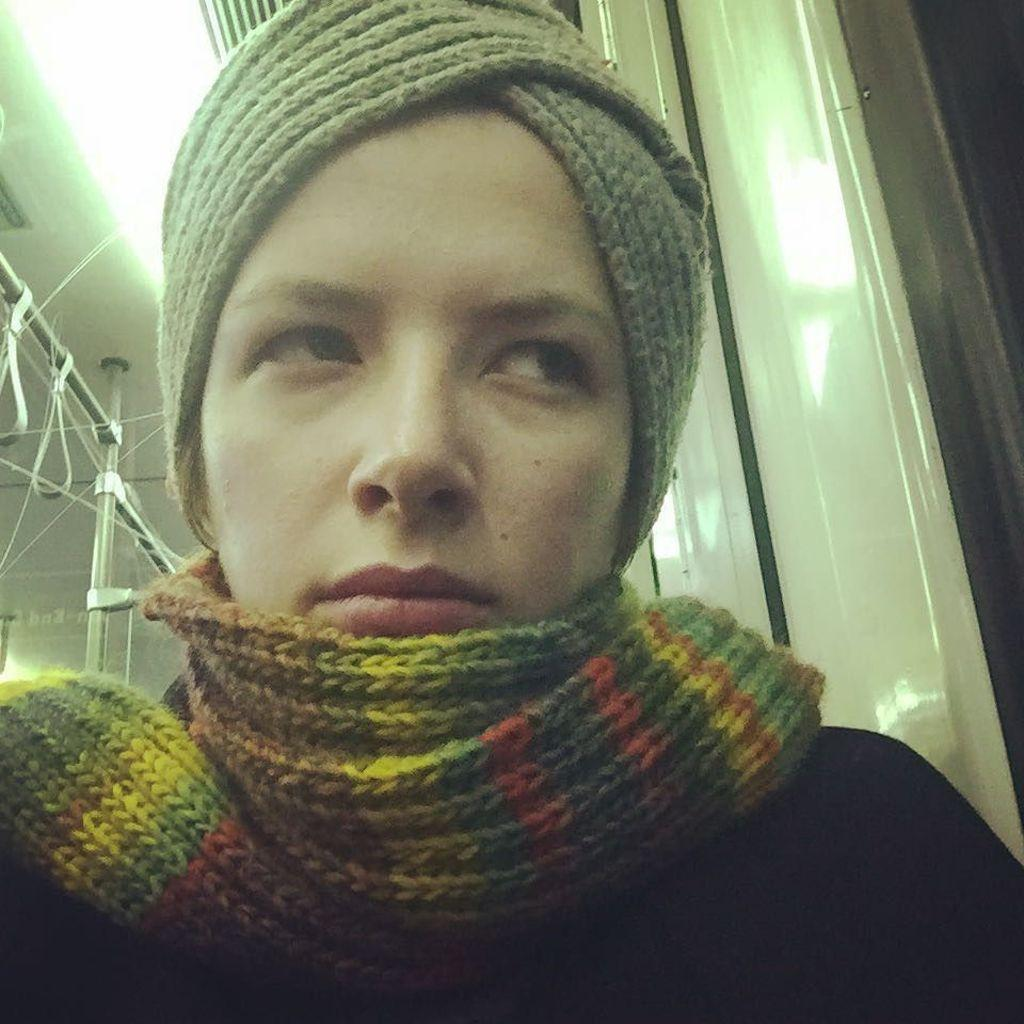Who or what is present in the image? There is a person in the image. What is the person wearing in the image? The person is wearing a scarf. What else can be seen in the image besides the person? There are rods in the image. What type of weather can be seen in the image? There is no indication of weather in the image, as it only features a person wearing a scarf and rods. 